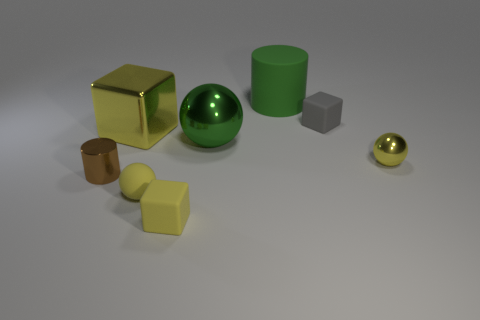Add 2 tiny gray cubes. How many objects exist? 10 Subtract all spheres. How many objects are left? 5 Subtract 0 cyan cylinders. How many objects are left? 8 Subtract all yellow metal spheres. Subtract all large yellow blocks. How many objects are left? 6 Add 3 small gray matte cubes. How many small gray matte cubes are left? 4 Add 7 metal blocks. How many metal blocks exist? 8 